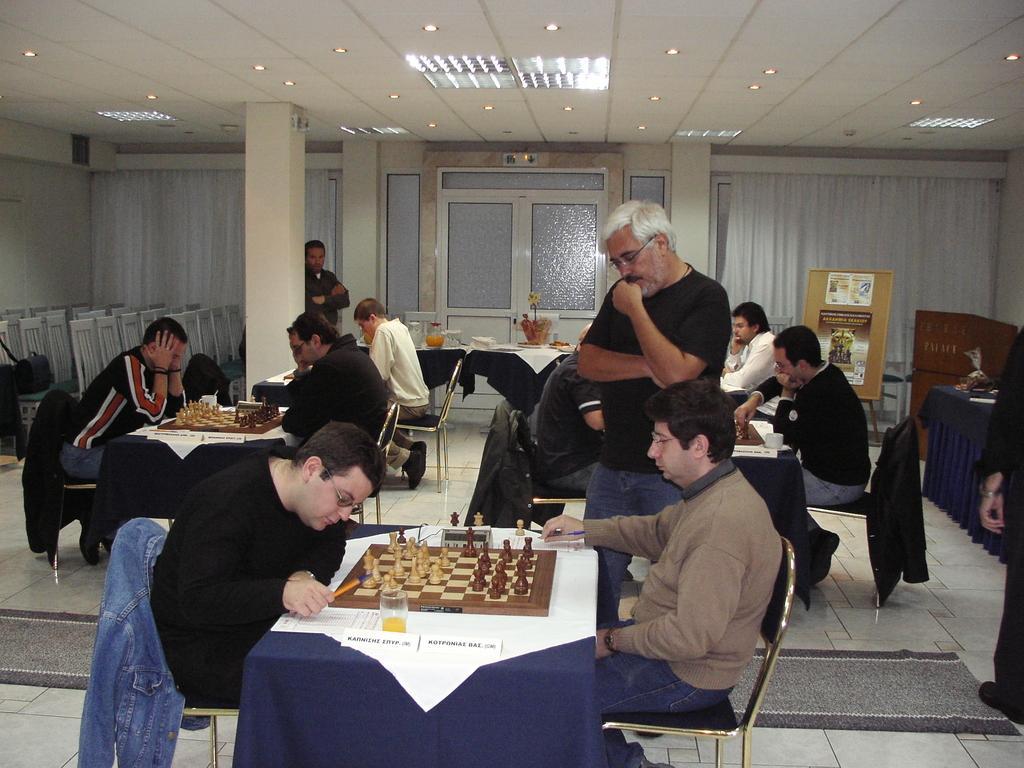In one or two sentences, can you explain what this image depicts? In the picture I can see two persons sitting in chairs and playing chess and there is a person wearing black T-shirt is standing beside them and there are few other persons playing chess behind them and there are few other persons and some other objects in the background. 